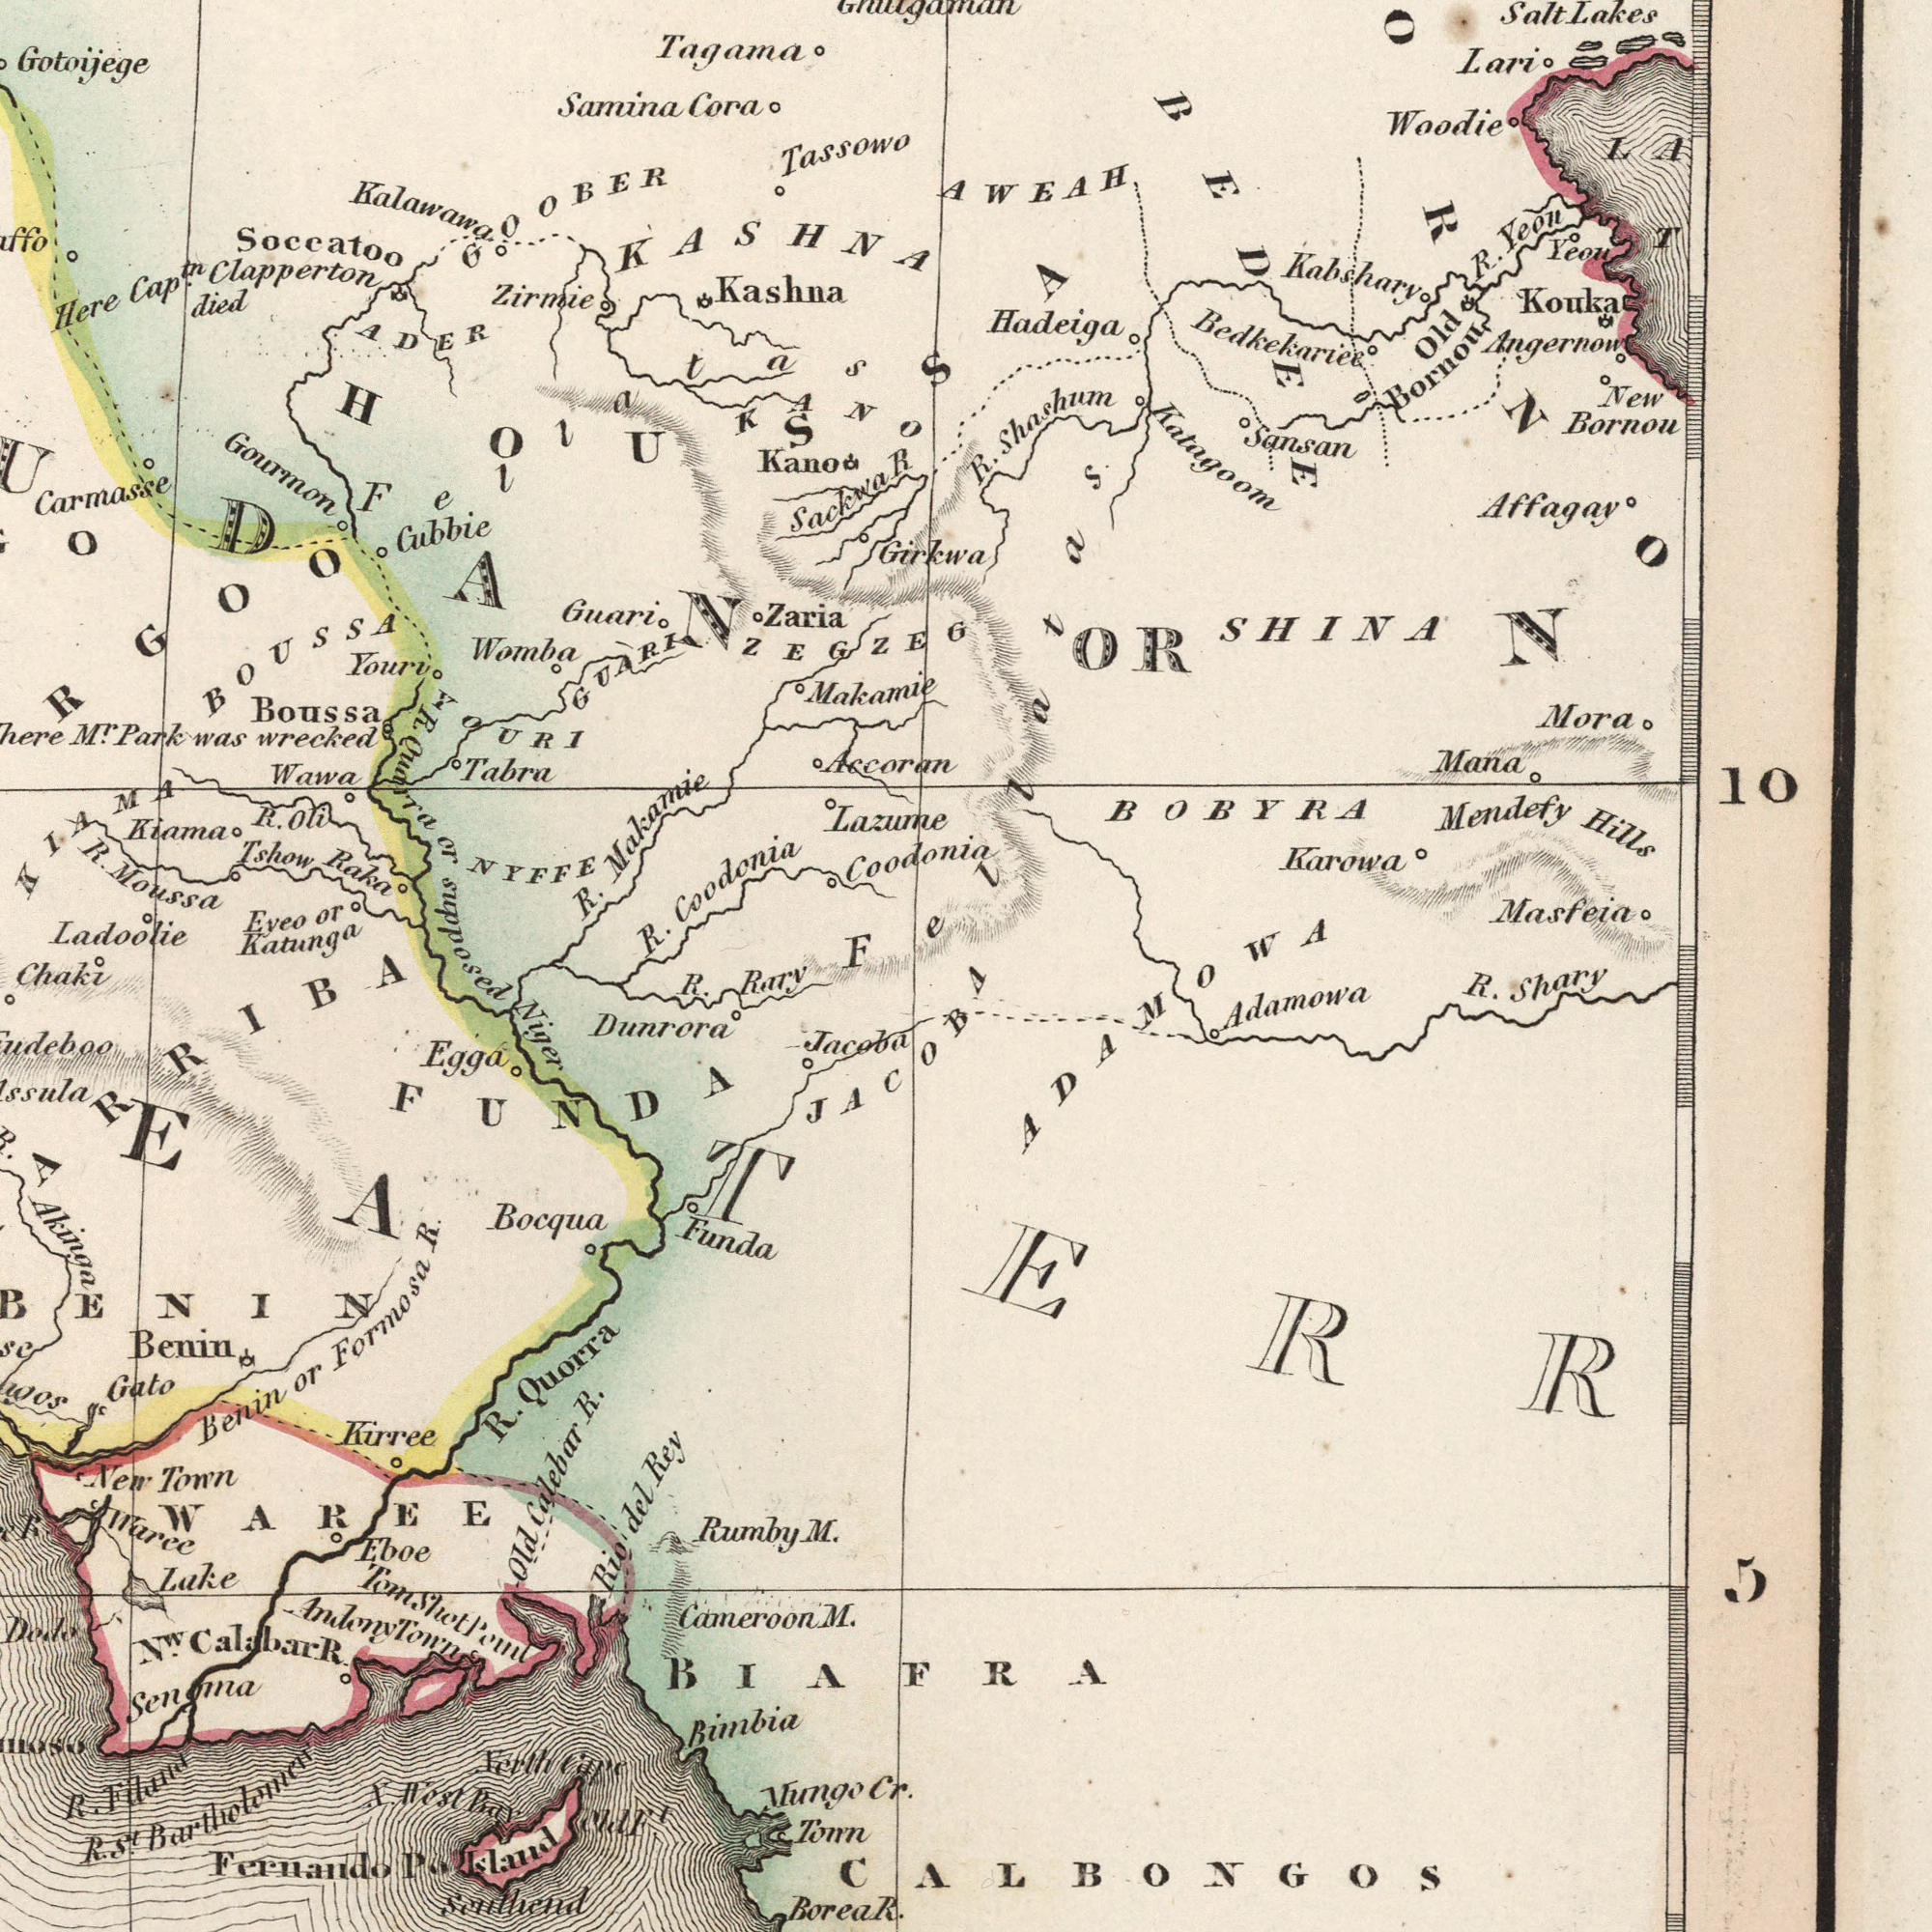What text can you see in the top-right section? Makamie Tassowo Lazume Girkwa Accoran ZEGZEG Coodoni Katagoom Masfeia AWEAH Hadeiga Bedkekariee Angernow Yeon Affagay BOBYRA Lari Mora Sansan Mana Karowa Kouka Woodie Old Bornou SHINA Kabshary Fellatas Salt Lakes R. Yeon R. Shashum R. New Bornou Mendefy Hills BEDEE What text is shown in the bottom-left quadrant? ###EA Bimbia Funda Senoma Gato ###erth ###e Dunrora Mungo Tonn Kurree Eboe Lake Benin Egga Bocqua ###R Waree Southend WAREE FUNDA ###ARRIBA Chaki BENIN Niger R. Rary R. Akinga Benin or Formosa R. R. Quorra Old Calebar R. Rio del Rey Rumby M. Cameroon M. Borea Fernando P. Island R. St. R. New Town N West Bay Nw. Calabar R. Andeny Town Tom Slot Pond What text can you see in the bottom-right section? Jacoba Cr. JACOBA BIAFRA CALBONGOS TERR Adamowa ADAMOWA R. Shary R. What text is visible in the upper-left corner? Carmasse Ladoolie Gotoÿege Eyeo or Katunga Here Cap.tn Clapperton died Kano Boussa BOUSSA Gourmon Tshow Raka Zaria Tagama Kashna Soccatoo Gubbie Tabra GOOBER Guari Womba Mr. Park was wrecked Wawa NYFFE ADER Youri Kalawawa GUARI Zirmie KIAMA KASHNA Kiama ###RGOO HOUSSA YOURI Fellatas Samina Cora Sackwa R. Moussa R. or supposed R. Makamie R. Coodonia R. Oli KANO 